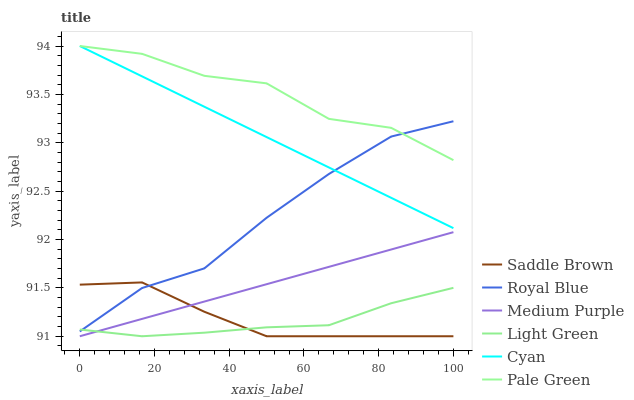Does Light Green have the minimum area under the curve?
Answer yes or no. Yes. Does Pale Green have the maximum area under the curve?
Answer yes or no. Yes. Does Royal Blue have the minimum area under the curve?
Answer yes or no. No. Does Royal Blue have the maximum area under the curve?
Answer yes or no. No. Is Cyan the smoothest?
Answer yes or no. Yes. Is Pale Green the roughest?
Answer yes or no. Yes. Is Royal Blue the smoothest?
Answer yes or no. No. Is Royal Blue the roughest?
Answer yes or no. No. Does Medium Purple have the lowest value?
Answer yes or no. Yes. Does Royal Blue have the lowest value?
Answer yes or no. No. Does Cyan have the highest value?
Answer yes or no. Yes. Does Royal Blue have the highest value?
Answer yes or no. No. Is Saddle Brown less than Cyan?
Answer yes or no. Yes. Is Pale Green greater than Saddle Brown?
Answer yes or no. Yes. Does Royal Blue intersect Saddle Brown?
Answer yes or no. Yes. Is Royal Blue less than Saddle Brown?
Answer yes or no. No. Is Royal Blue greater than Saddle Brown?
Answer yes or no. No. Does Saddle Brown intersect Cyan?
Answer yes or no. No. 